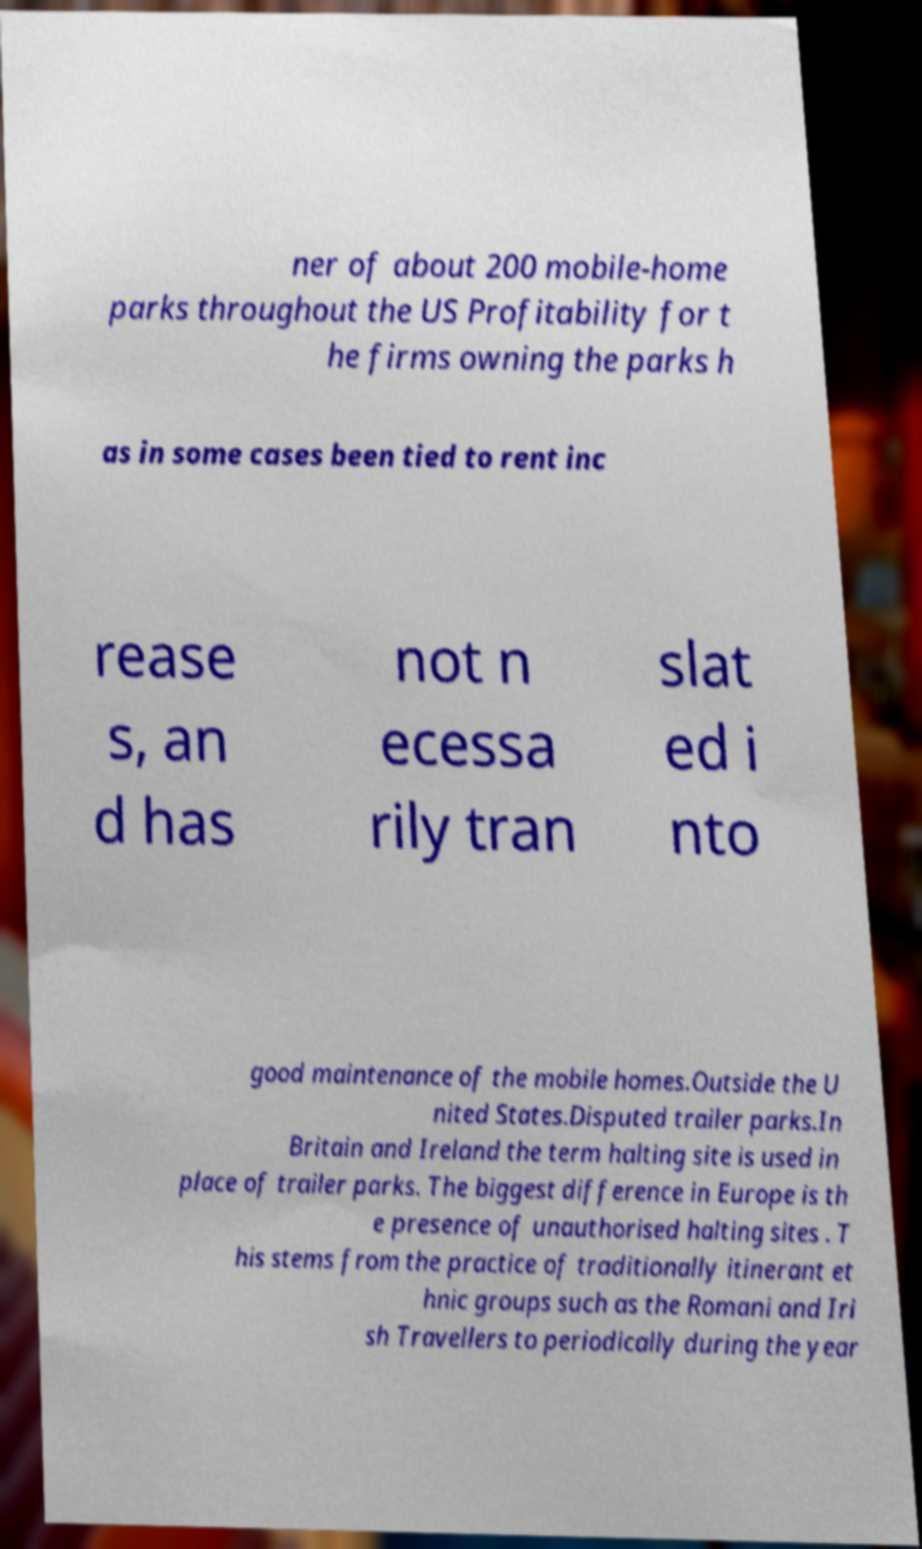Can you accurately transcribe the text from the provided image for me? ner of about 200 mobile-home parks throughout the US Profitability for t he firms owning the parks h as in some cases been tied to rent inc rease s, an d has not n ecessa rily tran slat ed i nto good maintenance of the mobile homes.Outside the U nited States.Disputed trailer parks.In Britain and Ireland the term halting site is used in place of trailer parks. The biggest difference in Europe is th e presence of unauthorised halting sites . T his stems from the practice of traditionally itinerant et hnic groups such as the Romani and Iri sh Travellers to periodically during the year 